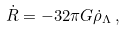<formula> <loc_0><loc_0><loc_500><loc_500>\dot { R } = - 3 2 \pi G \dot { \rho } _ { \Lambda } \, ,</formula> 